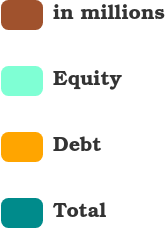Convert chart. <chart><loc_0><loc_0><loc_500><loc_500><pie_chart><fcel>in millions<fcel>Equity<fcel>Debt<fcel>Total<nl><fcel>21.53%<fcel>23.83%<fcel>15.8%<fcel>38.84%<nl></chart> 